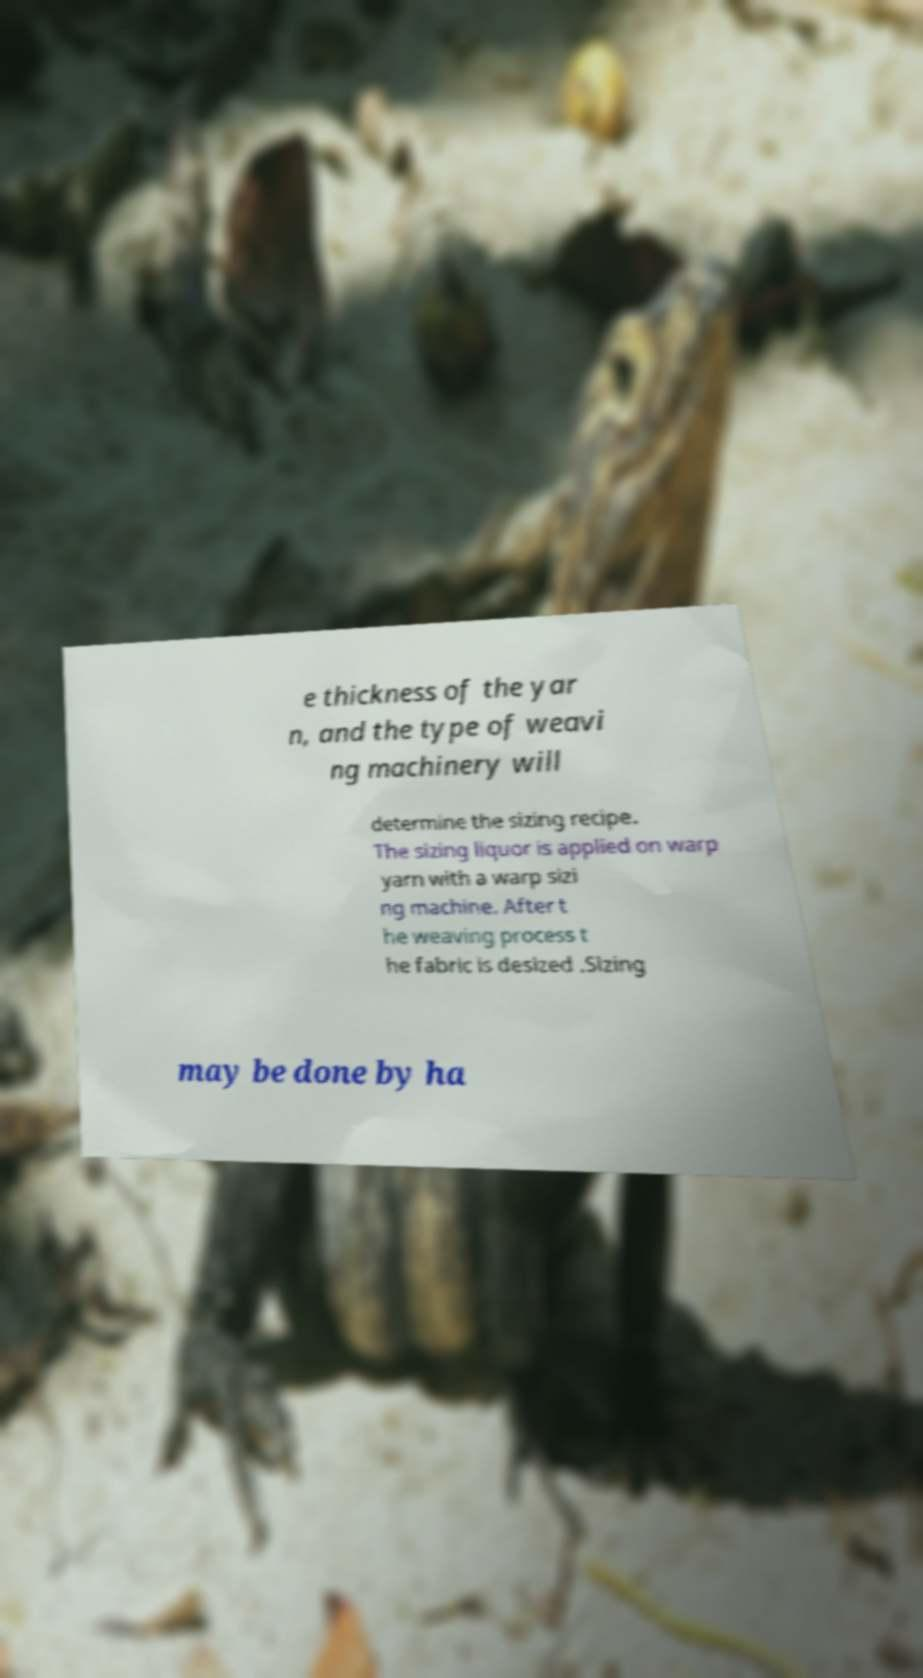Could you assist in decoding the text presented in this image and type it out clearly? e thickness of the yar n, and the type of weavi ng machinery will determine the sizing recipe. The sizing liquor is applied on warp yarn with a warp sizi ng machine. After t he weaving process t he fabric is desized .Sizing may be done by ha 